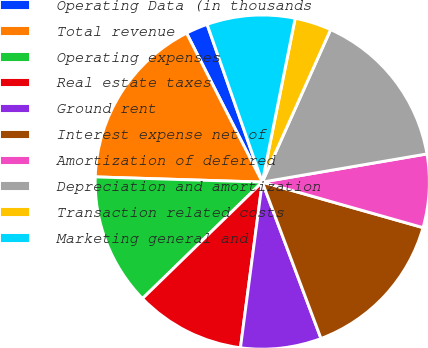Convert chart to OTSL. <chart><loc_0><loc_0><loc_500><loc_500><pie_chart><fcel>Operating Data (in thousands<fcel>Total revenue<fcel>Operating expenses<fcel>Real estate taxes<fcel>Ground rent<fcel>Interest expense net of<fcel>Amortization of deferred<fcel>Depreciation and amortization<fcel>Transaction related costs<fcel>Marketing general and<nl><fcel>2.13%<fcel>17.02%<fcel>12.77%<fcel>10.64%<fcel>7.8%<fcel>14.89%<fcel>7.09%<fcel>15.6%<fcel>3.55%<fcel>8.51%<nl></chart> 